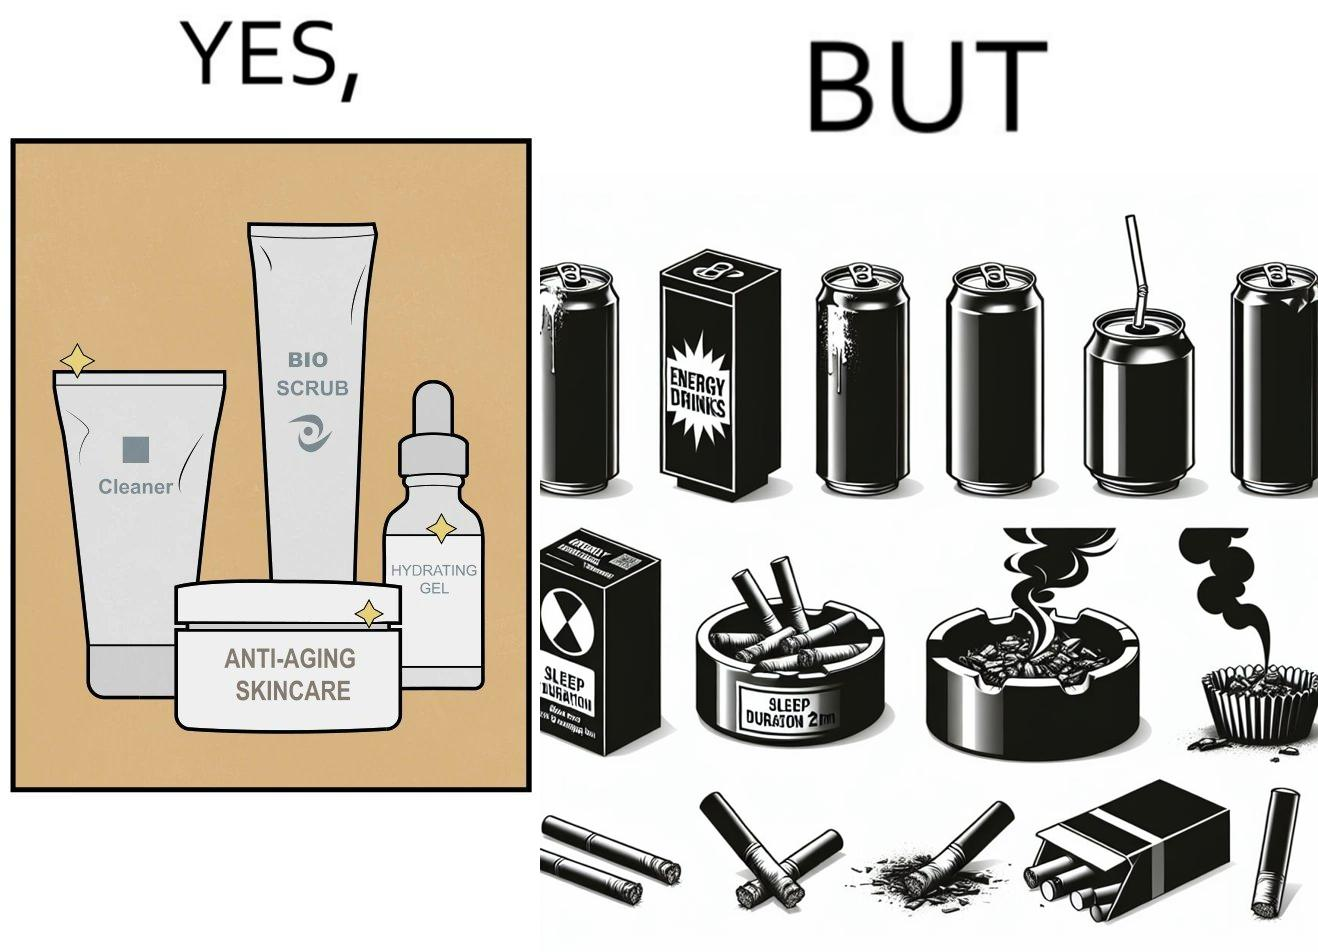Does this image contain satire or humor? Yes, this image is satirical. 